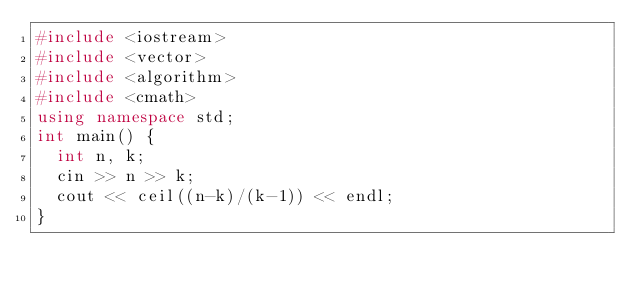Convert code to text. <code><loc_0><loc_0><loc_500><loc_500><_C++_>#include <iostream>
#include <vector>
#include <algorithm>
#include <cmath>
using namespace std;
int main() {
  int n, k;
  cin >> n >> k;
  cout << ceil((n-k)/(k-1)) << endl;
}</code> 